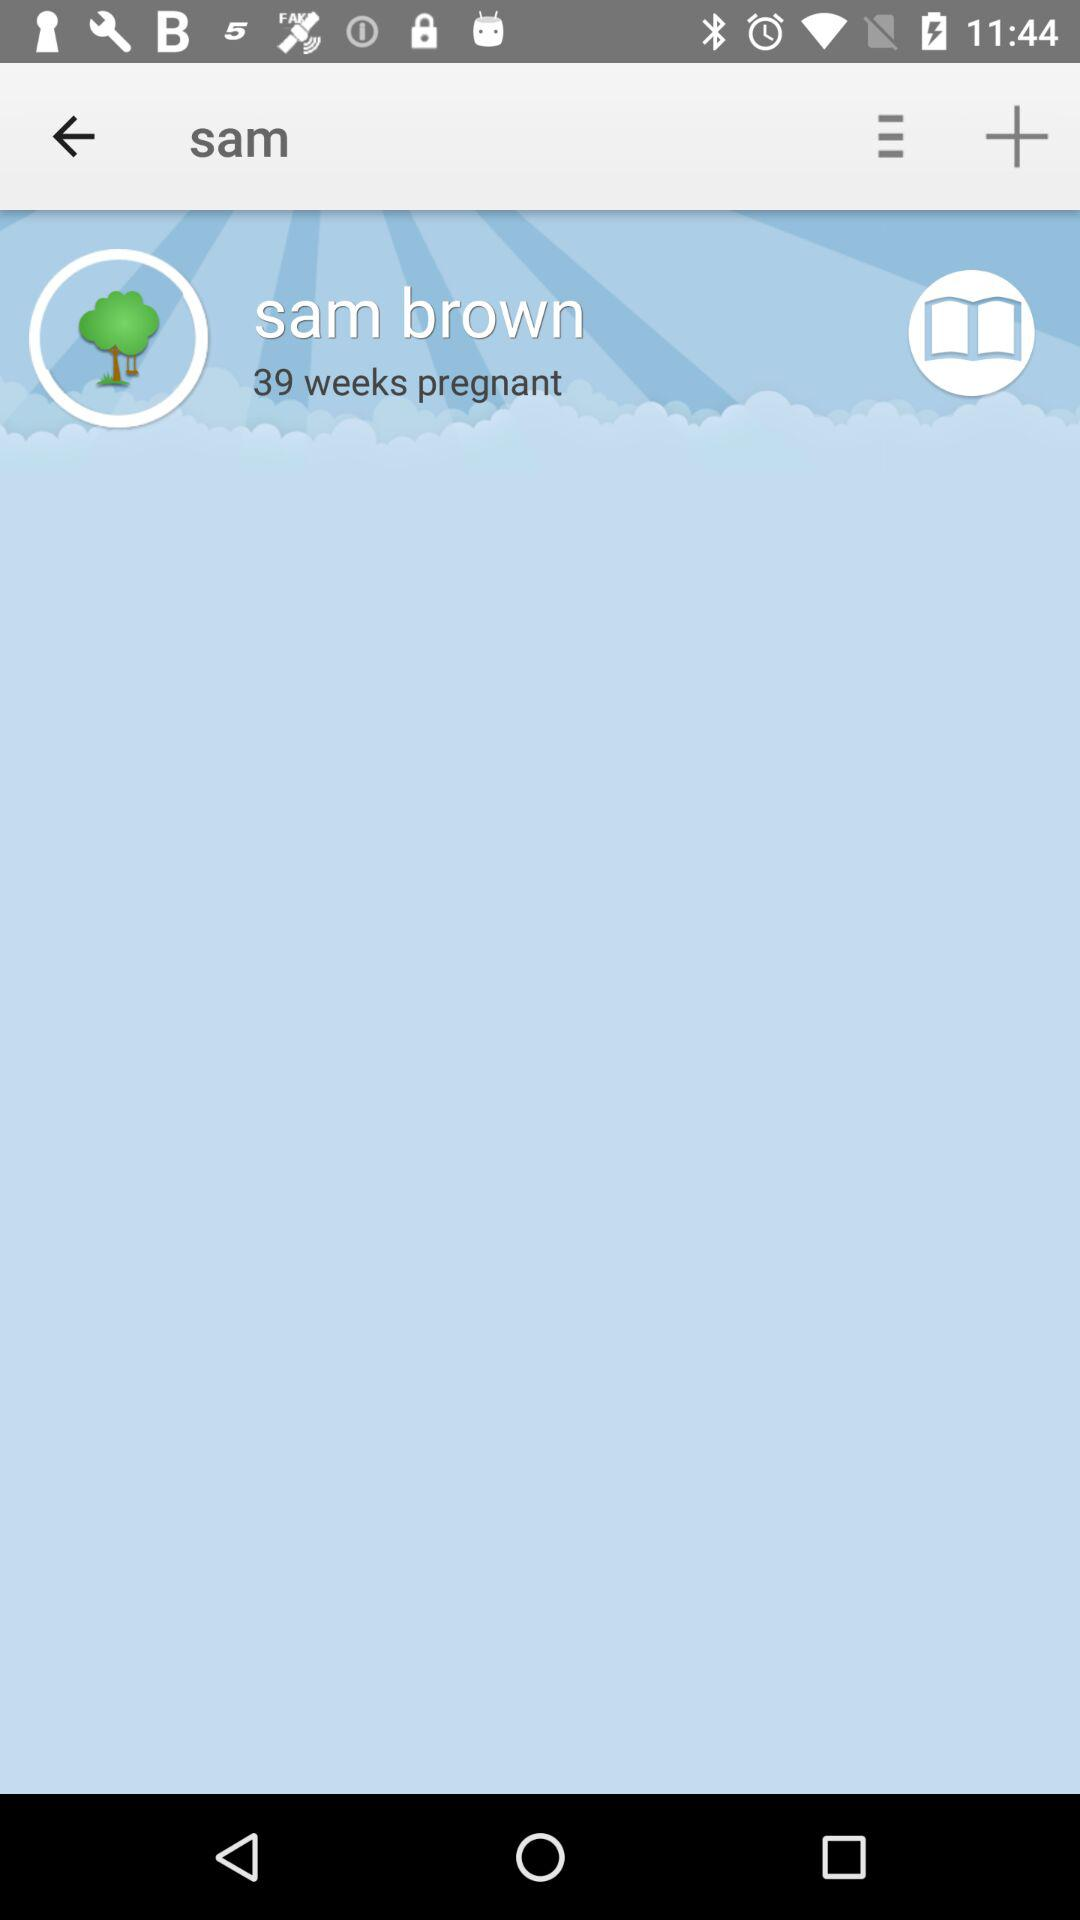How many weeks pregnant is Sam Brown?
Answer the question using a single word or phrase. 39 